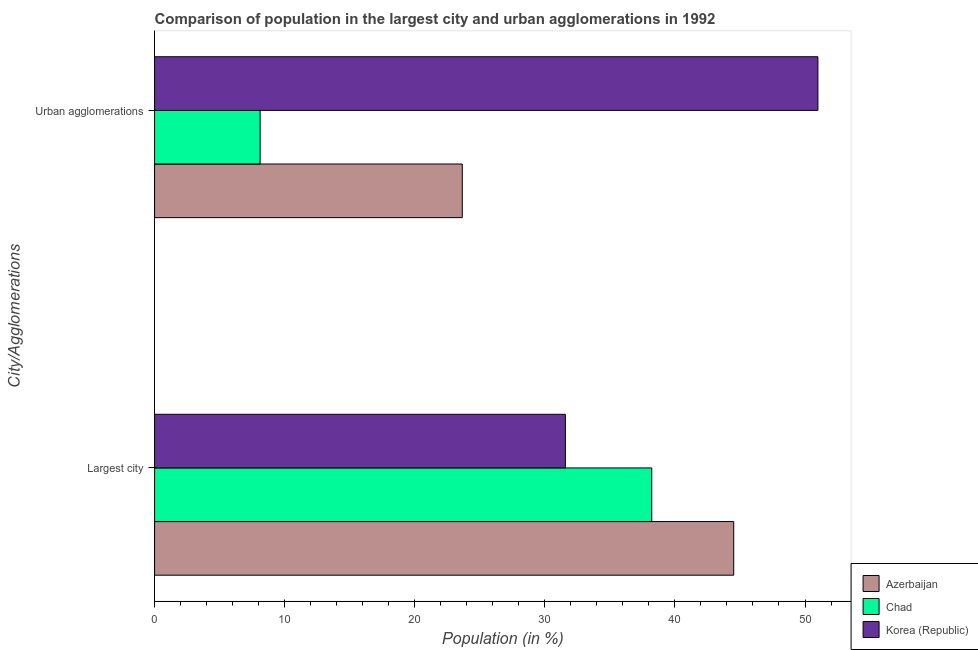How many different coloured bars are there?
Offer a terse response. 3. Are the number of bars per tick equal to the number of legend labels?
Your answer should be compact. Yes. How many bars are there on the 1st tick from the bottom?
Ensure brevity in your answer.  3. What is the label of the 2nd group of bars from the top?
Offer a terse response. Largest city. What is the population in urban agglomerations in Korea (Republic)?
Make the answer very short. 50.99. Across all countries, what is the maximum population in the largest city?
Your answer should be very brief. 44.52. Across all countries, what is the minimum population in the largest city?
Keep it short and to the point. 31.58. In which country was the population in the largest city maximum?
Your answer should be very brief. Azerbaijan. What is the total population in the largest city in the graph?
Provide a succinct answer. 114.32. What is the difference between the population in the largest city in Azerbaijan and that in Chad?
Ensure brevity in your answer.  6.3. What is the difference between the population in the largest city in Azerbaijan and the population in urban agglomerations in Korea (Republic)?
Your answer should be compact. -6.47. What is the average population in urban agglomerations per country?
Ensure brevity in your answer.  27.59. What is the difference between the population in urban agglomerations and population in the largest city in Azerbaijan?
Offer a very short reply. -20.87. What is the ratio of the population in the largest city in Chad to that in Korea (Republic)?
Ensure brevity in your answer.  1.21. Is the population in urban agglomerations in Korea (Republic) less than that in Azerbaijan?
Your answer should be very brief. No. In how many countries, is the population in urban agglomerations greater than the average population in urban agglomerations taken over all countries?
Your answer should be very brief. 1. What does the 3rd bar from the top in Urban agglomerations represents?
Ensure brevity in your answer.  Azerbaijan. Are all the bars in the graph horizontal?
Offer a very short reply. Yes. How many countries are there in the graph?
Offer a very short reply. 3. Are the values on the major ticks of X-axis written in scientific E-notation?
Your answer should be compact. No. Does the graph contain any zero values?
Keep it short and to the point. No. Where does the legend appear in the graph?
Your response must be concise. Bottom right. How many legend labels are there?
Your answer should be compact. 3. How are the legend labels stacked?
Your response must be concise. Vertical. What is the title of the graph?
Give a very brief answer. Comparison of population in the largest city and urban agglomerations in 1992. Does "San Marino" appear as one of the legend labels in the graph?
Offer a very short reply. No. What is the label or title of the Y-axis?
Your response must be concise. City/Agglomerations. What is the Population (in %) in Azerbaijan in Largest city?
Make the answer very short. 44.52. What is the Population (in %) of Chad in Largest city?
Offer a terse response. 38.22. What is the Population (in %) in Korea (Republic) in Largest city?
Keep it short and to the point. 31.58. What is the Population (in %) in Azerbaijan in Urban agglomerations?
Your answer should be very brief. 23.66. What is the Population (in %) in Chad in Urban agglomerations?
Your response must be concise. 8.12. What is the Population (in %) of Korea (Republic) in Urban agglomerations?
Offer a terse response. 50.99. Across all City/Agglomerations, what is the maximum Population (in %) in Azerbaijan?
Offer a very short reply. 44.52. Across all City/Agglomerations, what is the maximum Population (in %) in Chad?
Offer a terse response. 38.22. Across all City/Agglomerations, what is the maximum Population (in %) in Korea (Republic)?
Offer a terse response. 50.99. Across all City/Agglomerations, what is the minimum Population (in %) of Azerbaijan?
Ensure brevity in your answer.  23.66. Across all City/Agglomerations, what is the minimum Population (in %) of Chad?
Provide a succinct answer. 8.12. Across all City/Agglomerations, what is the minimum Population (in %) of Korea (Republic)?
Your answer should be compact. 31.58. What is the total Population (in %) of Azerbaijan in the graph?
Your answer should be compact. 68.18. What is the total Population (in %) in Chad in the graph?
Offer a very short reply. 46.34. What is the total Population (in %) in Korea (Republic) in the graph?
Ensure brevity in your answer.  82.57. What is the difference between the Population (in %) of Azerbaijan in Largest city and that in Urban agglomerations?
Ensure brevity in your answer.  20.87. What is the difference between the Population (in %) of Chad in Largest city and that in Urban agglomerations?
Your answer should be very brief. 30.1. What is the difference between the Population (in %) in Korea (Republic) in Largest city and that in Urban agglomerations?
Ensure brevity in your answer.  -19.41. What is the difference between the Population (in %) in Azerbaijan in Largest city and the Population (in %) in Chad in Urban agglomerations?
Make the answer very short. 36.41. What is the difference between the Population (in %) of Azerbaijan in Largest city and the Population (in %) of Korea (Republic) in Urban agglomerations?
Make the answer very short. -6.47. What is the difference between the Population (in %) of Chad in Largest city and the Population (in %) of Korea (Republic) in Urban agglomerations?
Ensure brevity in your answer.  -12.77. What is the average Population (in %) of Azerbaijan per City/Agglomerations?
Give a very brief answer. 34.09. What is the average Population (in %) in Chad per City/Agglomerations?
Your response must be concise. 23.17. What is the average Population (in %) of Korea (Republic) per City/Agglomerations?
Your answer should be compact. 41.29. What is the difference between the Population (in %) of Azerbaijan and Population (in %) of Chad in Largest city?
Make the answer very short. 6.3. What is the difference between the Population (in %) in Azerbaijan and Population (in %) in Korea (Republic) in Largest city?
Keep it short and to the point. 12.94. What is the difference between the Population (in %) of Chad and Population (in %) of Korea (Republic) in Largest city?
Offer a terse response. 6.64. What is the difference between the Population (in %) in Azerbaijan and Population (in %) in Chad in Urban agglomerations?
Provide a succinct answer. 15.54. What is the difference between the Population (in %) in Azerbaijan and Population (in %) in Korea (Republic) in Urban agglomerations?
Keep it short and to the point. -27.34. What is the difference between the Population (in %) of Chad and Population (in %) of Korea (Republic) in Urban agglomerations?
Offer a very short reply. -42.88. What is the ratio of the Population (in %) in Azerbaijan in Largest city to that in Urban agglomerations?
Offer a terse response. 1.88. What is the ratio of the Population (in %) of Chad in Largest city to that in Urban agglomerations?
Your answer should be very brief. 4.71. What is the ratio of the Population (in %) of Korea (Republic) in Largest city to that in Urban agglomerations?
Give a very brief answer. 0.62. What is the difference between the highest and the second highest Population (in %) of Azerbaijan?
Ensure brevity in your answer.  20.87. What is the difference between the highest and the second highest Population (in %) in Chad?
Provide a succinct answer. 30.1. What is the difference between the highest and the second highest Population (in %) in Korea (Republic)?
Your response must be concise. 19.41. What is the difference between the highest and the lowest Population (in %) of Azerbaijan?
Your answer should be very brief. 20.87. What is the difference between the highest and the lowest Population (in %) of Chad?
Your answer should be compact. 30.1. What is the difference between the highest and the lowest Population (in %) in Korea (Republic)?
Your answer should be compact. 19.41. 